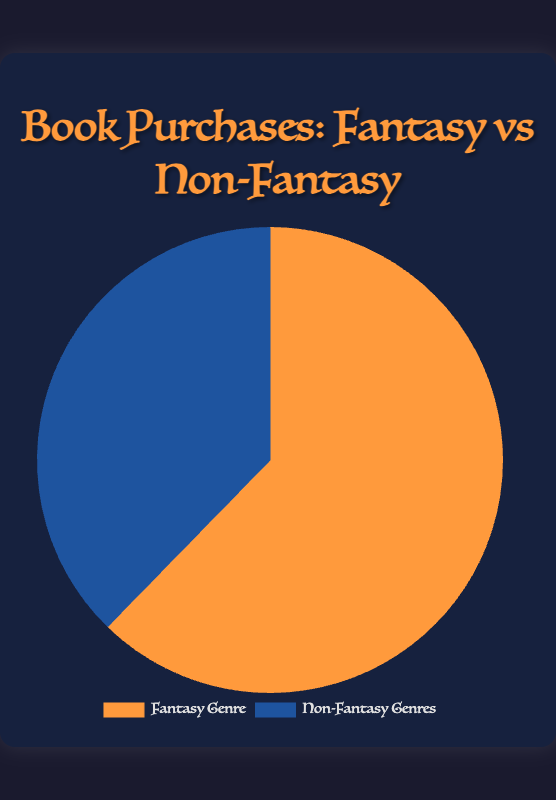What is the total number of book purchases? Add the number of fantasy and non-fantasy book purchases together: 623 (Fantasy Genre) + 377 (Non-Fantasy Genres) = 1000
Answer: 1000 Which genre has more book purchases? Compare the numbers: 623 (Fantasy Genre) is greater than 377 (Non-Fantasy Genres)
Answer: Fantasy Genre What percentage of book purchases are in the fantasy genre? Divide the number of fantasy purchases by the total and multiply by 100: (623 / 1000) * 100 = 62.3%
Answer: 62.3% What is the ratio of fantasy to non-fantasy book purchases? The ratio is found by dividing the number of fantasy book purchases by non-fantasy: 623 / 377 ≈ 1.65
Answer: 1.65 What is the difference in book purchases between fantasy and non-fantasy genres? Subtract the number of non-fantasy purchases from fantasy: 623 - 377 = 246
Answer: 246 How much larger is the fantasy section compared to the non-fantasy section? Calculate the proportion by dividing the difference by the non-fantasy purchases: 246 / 377 ≈ 0.65, then convert to percentage: 0.65 * 100 ≈ 65%
Answer: 65% Which color represents the non-fantasy genres in the pie chart? The description of visual attributes mentions the colors: The color representing non-fantasy genres is blue.
Answer: blue If 100 more books were added to the non-fantasy genre, what would be the new total number of book purchases? Add 100 to the current non-fantasy purchases: 377 + 100 = 477. Then, sum with the number of fantasy purchases: 623 + 477 = 1100
Answer: 1100 What would be the new percentage of non-fantasy book purchases if 100 more books were added to it? First, update the non-fantasy purchases: 377 + 100 = 477. Calculate the new total: 623 + 477 = 1100. Then, find the percentage of non-fantasy purchases: (477 / 1100) * 100 ≈ 43.36%
Answer: 43.36% Visually, which slice of the pie chart is larger? The pie chart description indicates that the fantasy genre slice would be larger due to the higher number of purchases (623) compared to non-fantasy (377).
Answer: Fantasy Genre 